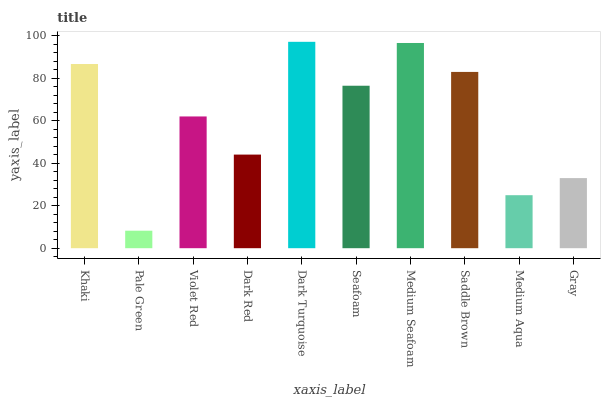Is Violet Red the minimum?
Answer yes or no. No. Is Violet Red the maximum?
Answer yes or no. No. Is Violet Red greater than Pale Green?
Answer yes or no. Yes. Is Pale Green less than Violet Red?
Answer yes or no. Yes. Is Pale Green greater than Violet Red?
Answer yes or no. No. Is Violet Red less than Pale Green?
Answer yes or no. No. Is Seafoam the high median?
Answer yes or no. Yes. Is Violet Red the low median?
Answer yes or no. Yes. Is Medium Aqua the high median?
Answer yes or no. No. Is Gray the low median?
Answer yes or no. No. 